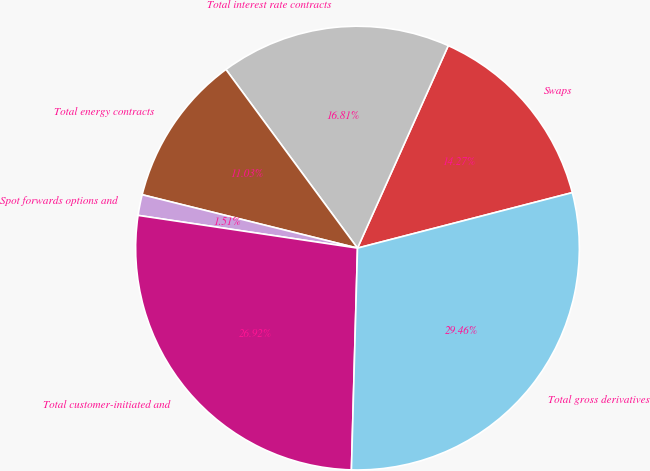Convert chart. <chart><loc_0><loc_0><loc_500><loc_500><pie_chart><fcel>Swaps<fcel>Total interest rate contracts<fcel>Total energy contracts<fcel>Spot forwards options and<fcel>Total customer-initiated and<fcel>Total gross derivatives<nl><fcel>14.27%<fcel>16.81%<fcel>11.03%<fcel>1.51%<fcel>26.92%<fcel>29.46%<nl></chart> 